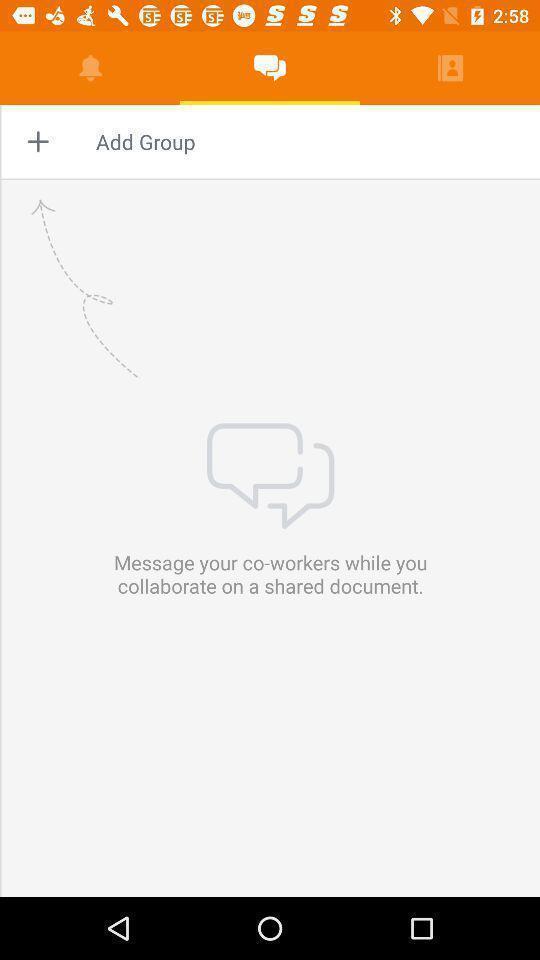Tell me what you see in this picture. Page that displaying to add group. 